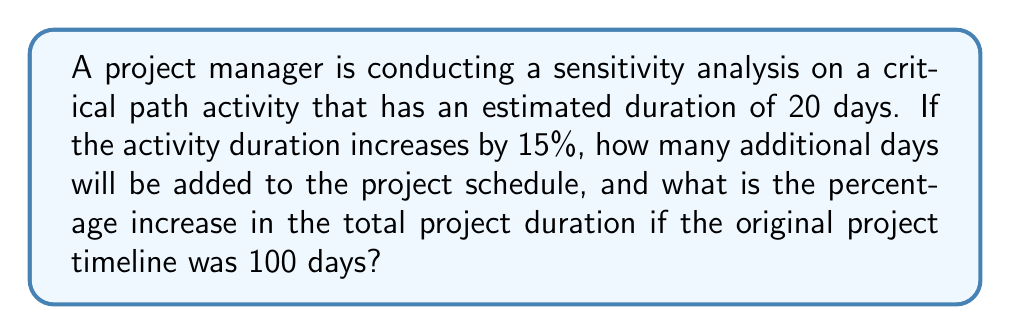Can you answer this question? Let's break this down step-by-step:

1. Calculate the increase in activity duration:
   * Original duration = 20 days
   * Increase percentage = 15%
   * Increase in days = $20 \times 15\% = 20 \times 0.15 = 3$ days

2. Calculate the new activity duration:
   * New duration = Original duration + Increase in days
   * New duration = $20 + 3 = 23$ days

3. Calculate the additional days added to the project schedule:
   * Additional days = New duration - Original duration
   * Additional days = $23 - 20 = 3$ days

4. Calculate the percentage increase in total project duration:
   * Original project duration = 100 days
   * New project duration = $100 + 3 = 103$ days
   * Percentage increase = $\frac{\text{Increase}}{\text{Original}} \times 100\%$
   * Percentage increase = $\frac{3}{100} \times 100\% = 3\%$

Therefore, the activity duration increase adds 3 days to the project schedule and increases the total project duration by 3%.
Answer: 3 days; 3% 